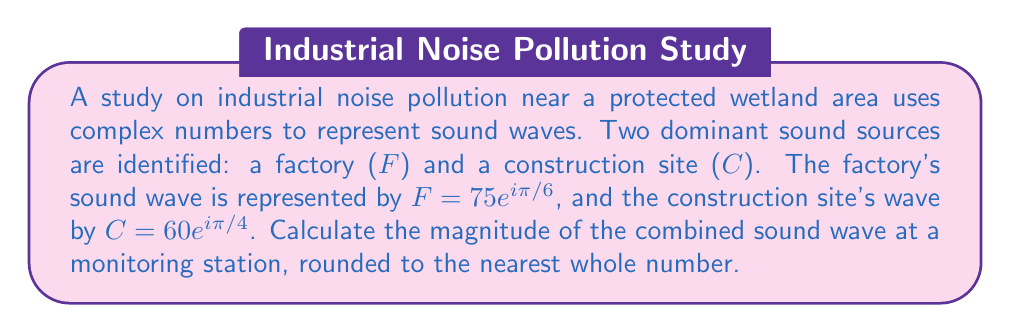Could you help me with this problem? To solve this problem, we'll follow these steps:

1) The combined sound wave is the sum of the two individual waves:
   $$T = F + C = 75e^{i\pi/6} + 60e^{i\pi/4}$$

2) To add these complex numbers, we need to convert them to rectangular form:
   
   For $F$: $75e^{i\pi/6} = 75(\cos(\pi/6) + i\sin(\pi/6))$
            $= 75(\frac{\sqrt{3}}{2} + i\frac{1}{2}) = 64.95 + 37.5i$
   
   For $C$: $60e^{i\pi/4} = 60(\cos(\pi/4) + i\sin(\pi/4))$
            $= 60(\frac{\sqrt{2}}{2} + i\frac{\sqrt{2}}{2}) = 42.43 + 42.43i$

3) Now we can add these:
   $$T = (64.95 + 37.5i) + (42.43 + 42.43i) = 107.38 + 79.93i$$

4) To find the magnitude of this combined wave, we use the formula:
   $$|T| = \sqrt{(107.38)^2 + (79.93)^2}$$

5) Calculating:
   $$|T| = \sqrt{11530.48 + 6388.81} = \sqrt{17919.29} \approx 133.86$$

6) Rounding to the nearest whole number:
   $$|T| \approx 134$$
Answer: 134 